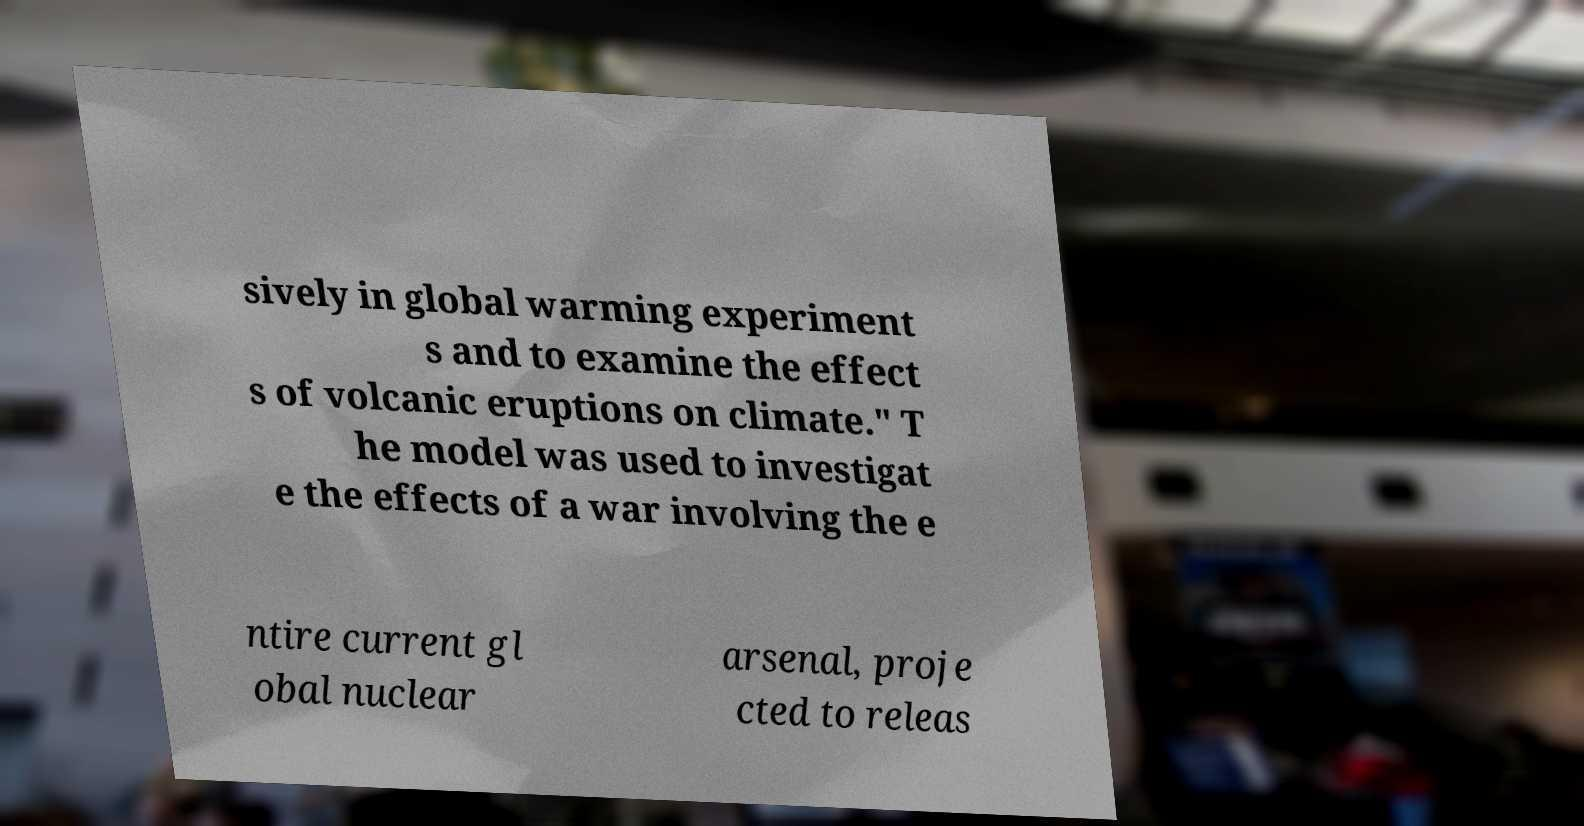Could you extract and type out the text from this image? sively in global warming experiment s and to examine the effect s of volcanic eruptions on climate." T he model was used to investigat e the effects of a war involving the e ntire current gl obal nuclear arsenal, proje cted to releas 